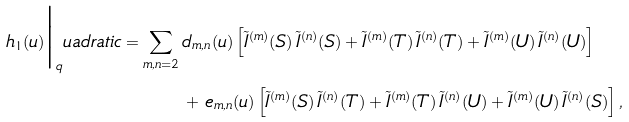<formula> <loc_0><loc_0><loc_500><loc_500>h _ { 1 } ( u ) \Big | _ { q } u a d r a t i c = \sum _ { m , n = 2 } \, & d _ { m , n } ( u ) \, \Big [ \tilde { I } ^ { ( m ) } ( S ) \, \tilde { I } ^ { ( n ) } ( S ) + \tilde { I } ^ { ( m ) } ( T ) \, \tilde { I } ^ { ( n ) } ( T ) + \tilde { I } ^ { ( m ) } ( U ) \, \tilde { I } ^ { ( n ) } ( U ) \Big ] \\ & + \, e _ { m , n } ( u ) \, \Big [ \tilde { I } ^ { ( m ) } ( S ) \, \tilde { I } ^ { ( n ) } ( T ) + \tilde { I } ^ { ( m ) } ( T ) \, \tilde { I } ^ { ( n ) } ( U ) + \tilde { I } ^ { ( m ) } ( U ) \, \tilde { I } ^ { ( n ) } ( S ) \Big ] \, ,</formula> 